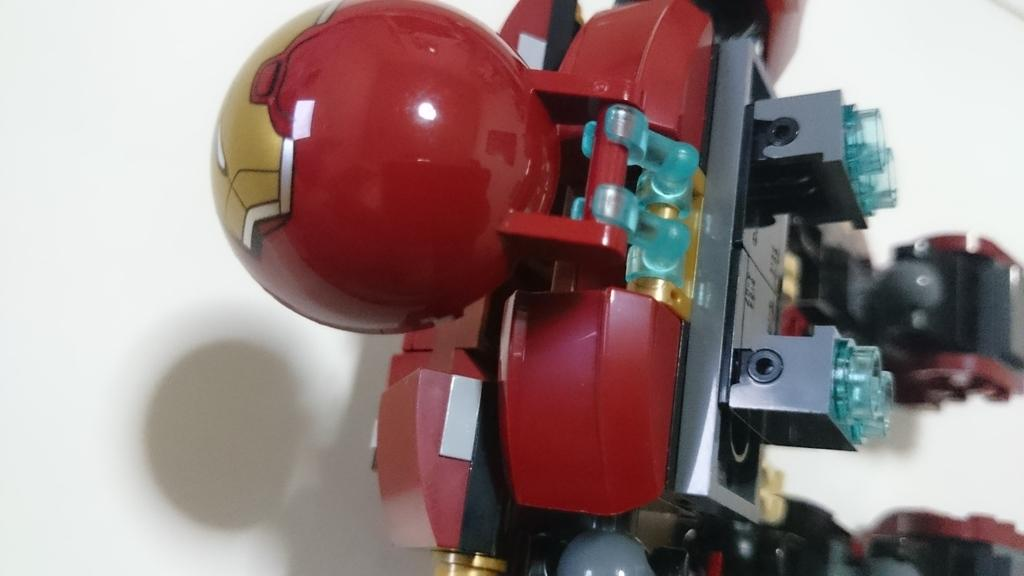What object is present in the image? There is a toy in the image. What is the color of the toy? The toy is red in color. On what surface is the toy placed? The toy is placed on a white surface. What type of circle is used to cast the toy in the image? There is no circle or casting process mentioned or depicted in the image; it simply shows a red toy placed on a white surface. Can you see a zipper on the toy in the image? There is no zipper visible on the toy in the image. 